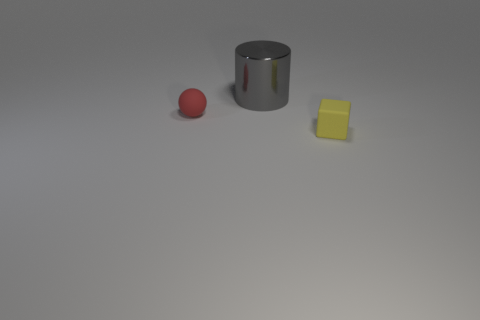What is the color of the rubber cube?
Your answer should be very brief. Yellow. What number of big things are red things or metallic cylinders?
Offer a very short reply. 1. Is the tiny thing that is behind the tiny rubber cube made of the same material as the object behind the red matte sphere?
Offer a terse response. No. Is there a tiny green ball?
Ensure brevity in your answer.  No. Are there more big metallic things that are left of the red thing than yellow objects in front of the small yellow block?
Your response must be concise. No. Are there any other things that have the same size as the red matte sphere?
Your answer should be compact. Yes. There is a tiny object that is to the left of the gray object; does it have the same color as the rubber object that is on the right side of the cylinder?
Ensure brevity in your answer.  No. What shape is the gray metallic thing?
Make the answer very short. Cylinder. Is the number of tiny red balls that are to the right of the small yellow matte cube greater than the number of gray shiny blocks?
Provide a short and direct response. No. There is a tiny object that is in front of the sphere; what shape is it?
Make the answer very short. Cube. 